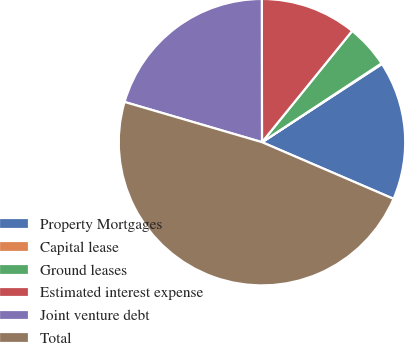Convert chart. <chart><loc_0><loc_0><loc_500><loc_500><pie_chart><fcel>Property Mortgages<fcel>Capital lease<fcel>Ground leases<fcel>Estimated interest expense<fcel>Joint venture debt<fcel>Total<nl><fcel>15.66%<fcel>0.09%<fcel>4.88%<fcel>10.86%<fcel>20.45%<fcel>48.06%<nl></chart> 